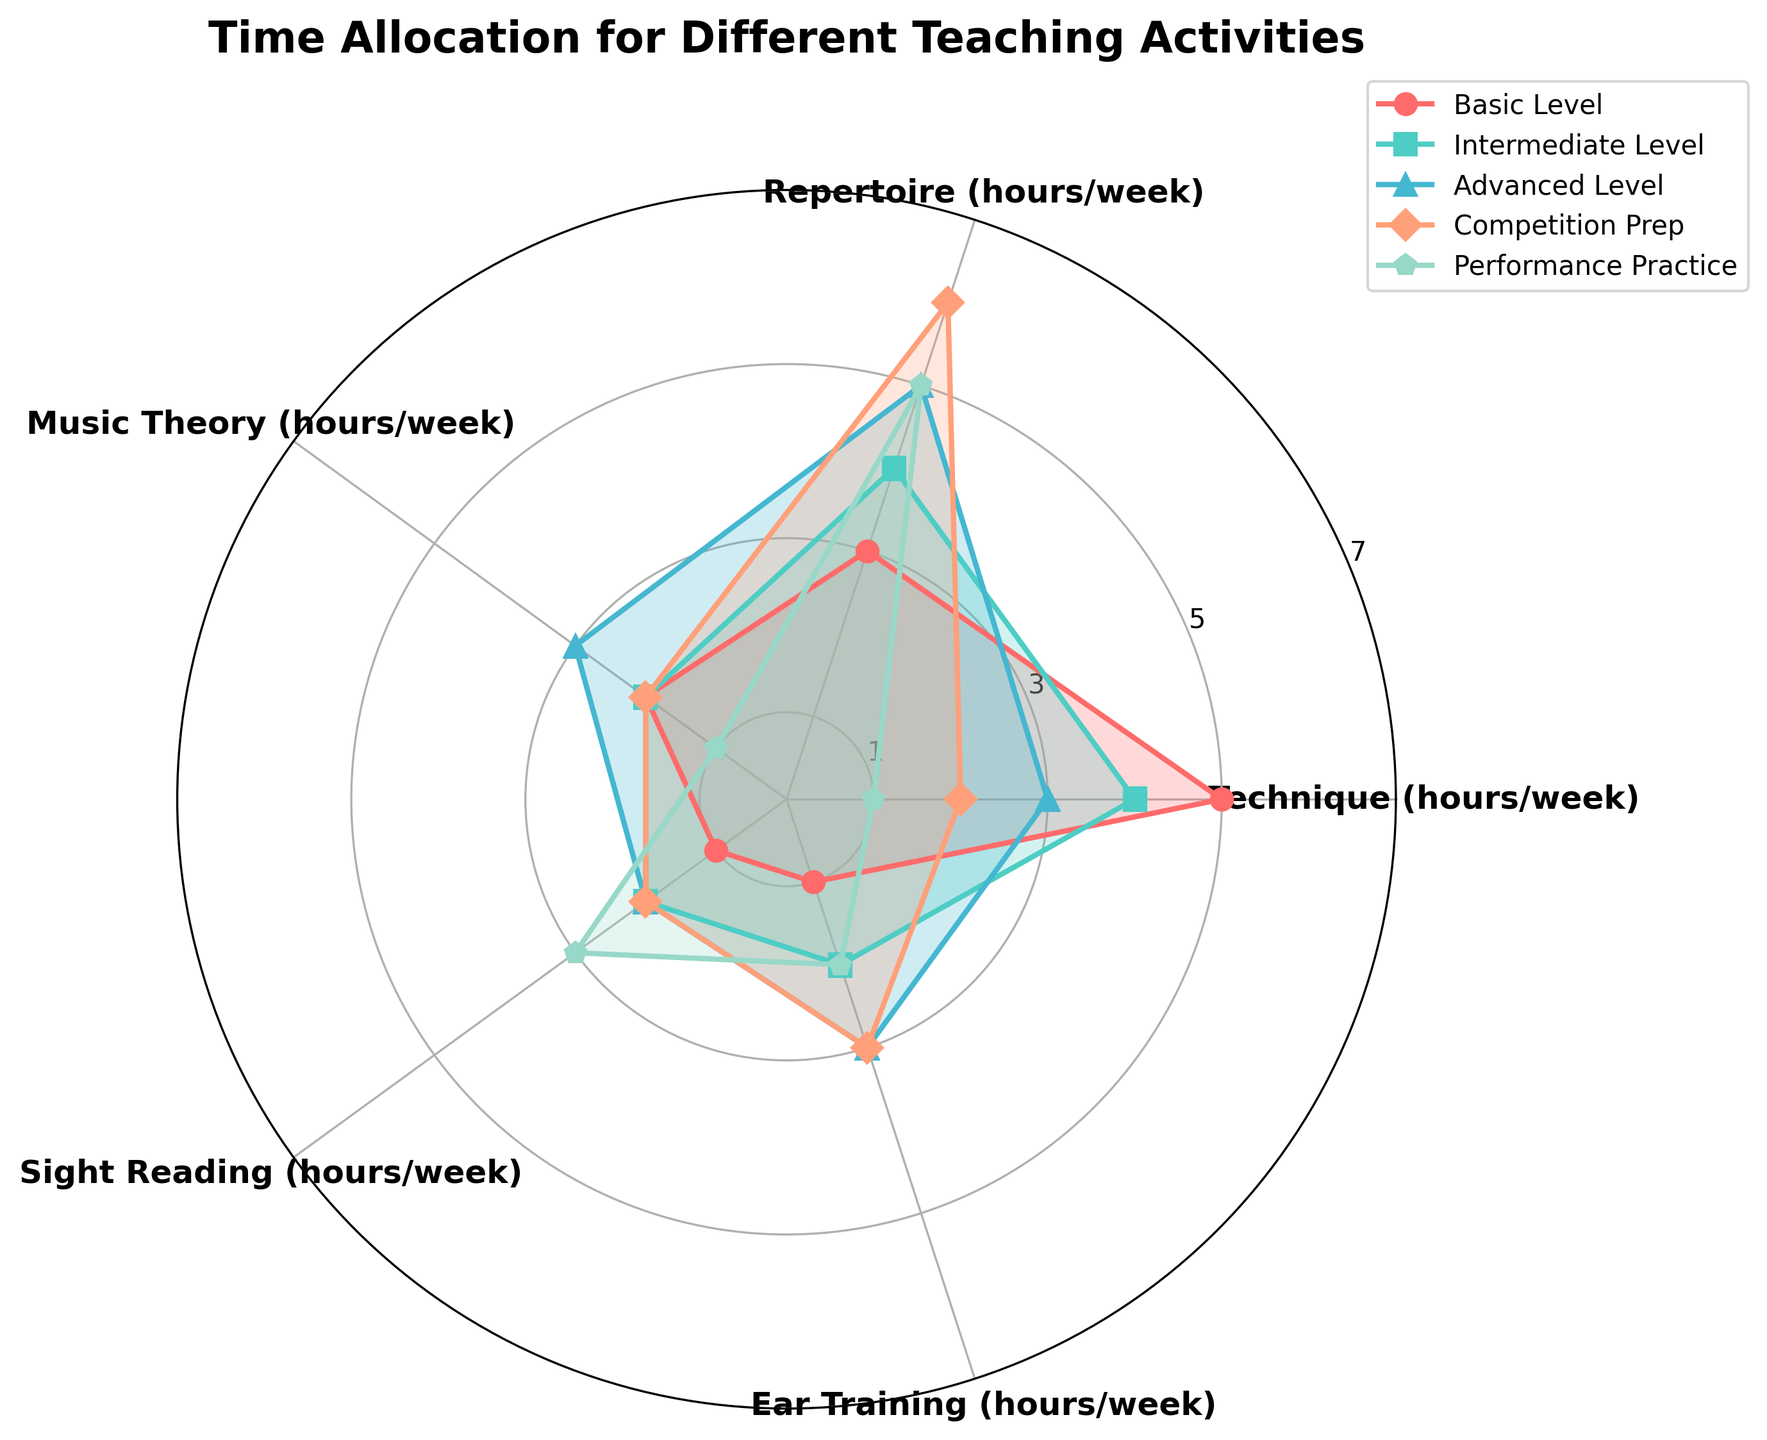What is the title of the Polar Chart? The title is prominently displayed at the top of the chart.
Answer: "Time Allocation for Different Teaching Activities" How many teaching activities are compared in the Polar Chart? By counting the distinct colored plots in the chart, there are five teaching activities as represented by the legend.
Answer: 5 Which activity allocates the most time to Technique? For Technique, which is one of the axes, the maximum value (5 hours) is found in the plot corresponding to "Basic Level".
Answer: Basic Level What is the total weekly time allocation for Music Theory across all teaching activities? Sum the Music Theory times (2 + 2 + 3 + 2 + 1) hours from all activities.
Answer: 10 hours How do the weekly hours for Repertoire differ between Basic Level and Competition Prep? Look at the Repertoire values for Basic Level (3 hours) and Competition Prep (6 hours). The difference is 6 - 3.
Answer: 3 hours Which teaching activity dedicates the most time to Sight Reading? For Sight Reading, look for the highest value (3 hours). This value is present in "Performance Practice".
Answer: Performance Practice If you averaged Ear Training across all teaching activities, what would it be? Add the Ear Training hours from all levels (1 + 2 + 3 + 3 + 2) and divide by the number of activities (5).
Answer: 2.2 hours Which two activities spend equal time for Sight Reading? Check the Sight Reading values. Both "Intermediate Level" and "Competition Prep" allocate 2 hours.
Answer: Intermediate Level and Competition Prep For the Advanced Level, is the time allocated to Music Theory more than that for Ear Training? Compare the values: Music Theory (3 hours) vs. Ear Training (3 hours). They are equal.
Answer: No, they are equal 